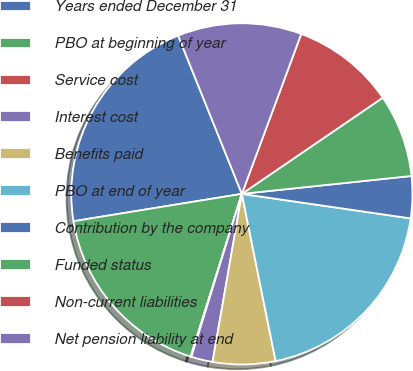Convert chart. <chart><loc_0><loc_0><loc_500><loc_500><pie_chart><fcel>Years ended December 31<fcel>PBO at beginning of year<fcel>Service cost<fcel>Interest cost<fcel>Benefits paid<fcel>PBO at end of year<fcel>Contribution by the company<fcel>Funded status<fcel>Non-current liabilities<fcel>Net pension liability at end<nl><fcel>21.47%<fcel>17.58%<fcel>0.08%<fcel>2.03%<fcel>5.92%<fcel>19.53%<fcel>3.97%<fcel>7.86%<fcel>9.81%<fcel>11.75%<nl></chart> 